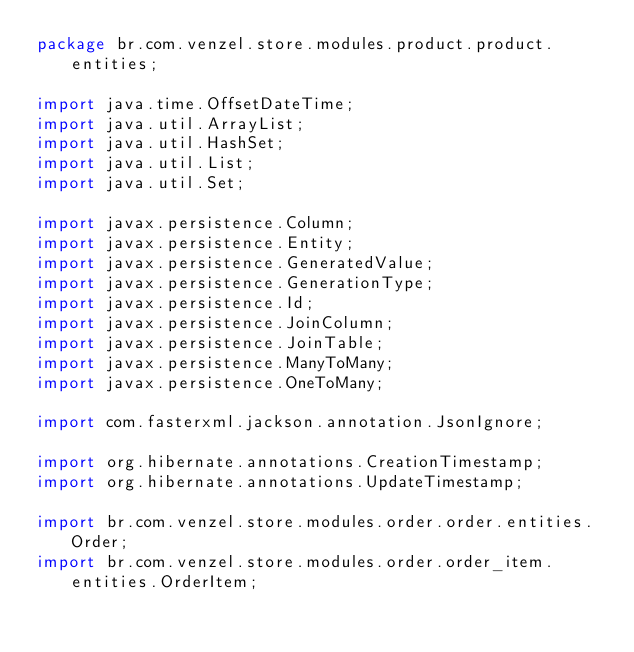Convert code to text. <code><loc_0><loc_0><loc_500><loc_500><_Java_>package br.com.venzel.store.modules.product.product.entities;

import java.time.OffsetDateTime;
import java.util.ArrayList;
import java.util.HashSet;
import java.util.List;
import java.util.Set;

import javax.persistence.Column;
import javax.persistence.Entity;
import javax.persistence.GeneratedValue;
import javax.persistence.GenerationType;
import javax.persistence.Id;
import javax.persistence.JoinColumn;
import javax.persistence.JoinTable;
import javax.persistence.ManyToMany;
import javax.persistence.OneToMany;

import com.fasterxml.jackson.annotation.JsonIgnore;

import org.hibernate.annotations.CreationTimestamp;
import org.hibernate.annotations.UpdateTimestamp;

import br.com.venzel.store.modules.order.order.entities.Order;
import br.com.venzel.store.modules.order.order_item.entities.OrderItem;</code> 